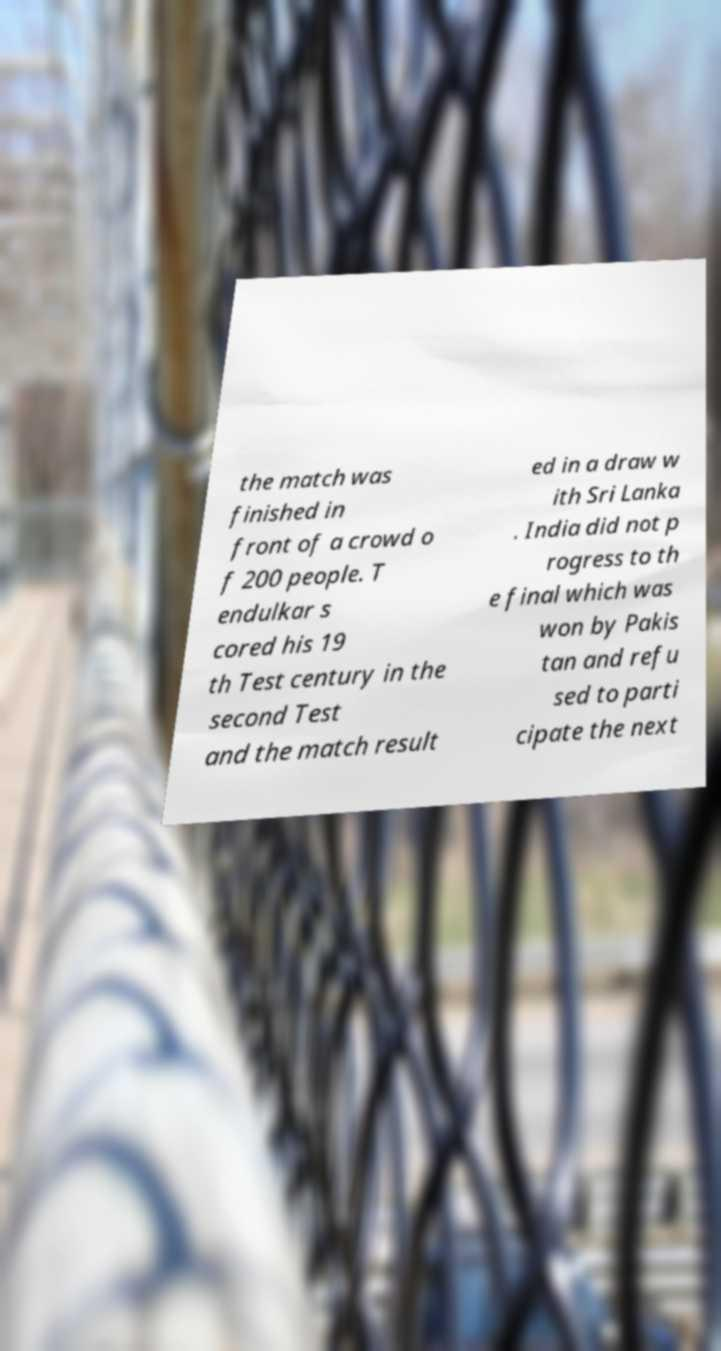Please read and relay the text visible in this image. What does it say? the match was finished in front of a crowd o f 200 people. T endulkar s cored his 19 th Test century in the second Test and the match result ed in a draw w ith Sri Lanka . India did not p rogress to th e final which was won by Pakis tan and refu sed to parti cipate the next 